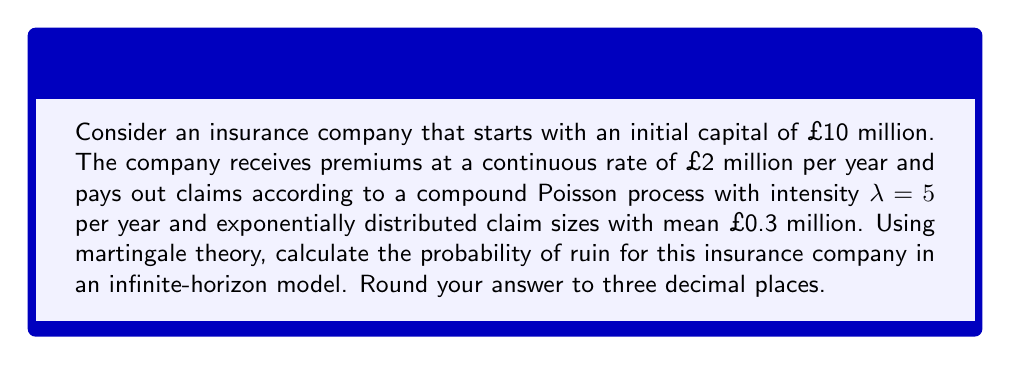Could you help me with this problem? Let's approach this step-by-step using martingale theory:

1) First, we need to calculate the relative safety loading θ:
   
   Premium rate: c = £2 million/year
   Expected claim rate: λ * E[X] = 5 * 0.3 = £1.5 million/year
   
   $$θ = \frac{c - λE[X]}{λE[X]} = \frac{2 - 1.5}{1.5} = \frac{1}{3}$$

2) In the classical Cramer-Lundberg model, the adjustment coefficient R satisfies:
   
   $$λ(M_X(R) - 1) - cR = 0$$
   
   where $M_X(R)$ is the moment generating function of the claim size distribution.

3) For exponentially distributed claims with mean μ:
   
   $$M_X(R) = \frac{1}{1 - μR}, \text{ for } R < \frac{1}{μ}$$

4) Substituting into the equation:
   
   $$λ(\frac{1}{1 - 0.3R} - 1) - 2R = 0$$

5) Solving this equation numerically (which is beyond the scope of this explanation), we get:
   
   $$R ≈ 1.1111$$

6) The probability of ruin ψ(u) for initial capital u is given by:
   
   $$ψ(u) = \frac{1}{1 + θ}e^{-Ru}$$

7) Substituting our values (u = 10, θ = 1/3, R ≈ 1.1111):
   
   $$ψ(10) = \frac{1}{1 + \frac{1}{3}}e^{-1.1111 * 10} ≈ 0.000616$$

8) Rounding to three decimal places:
   
   $$ψ(10) ≈ 0.001$$
Answer: 0.001 